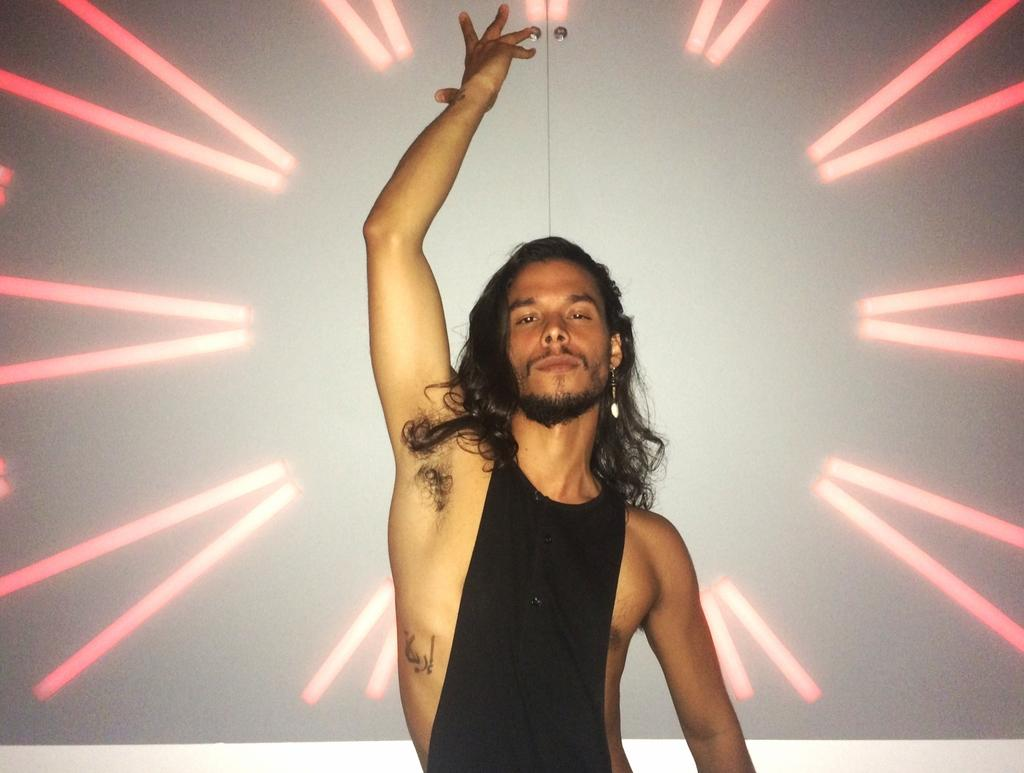What is the color of the background in the image? The background of the image is white. What can be seen in the image besides the background? There are lights visible in the image, as well as a man. What is the man wearing in the image? The man is wearing black attire. What is the man doing in the image? The man is giving a pose. What direction is the water flowing in the image? There is no water present in the image. What type of sound can be heard coming from the man in the image? There is no sound present in the image, as it is a still photograph. 